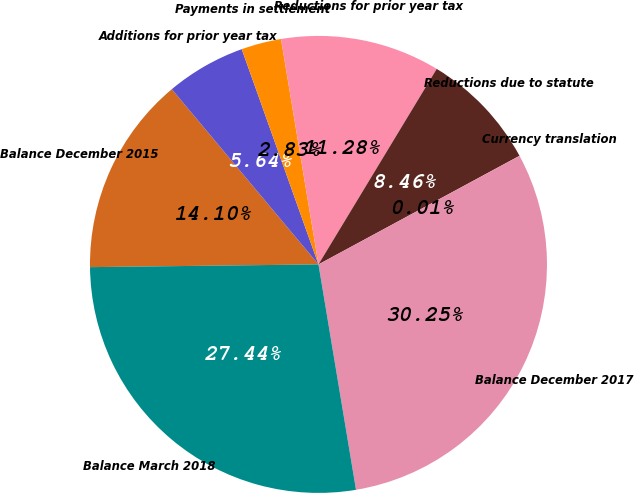Convert chart to OTSL. <chart><loc_0><loc_0><loc_500><loc_500><pie_chart><fcel>Balance December 2015<fcel>Additions for prior year tax<fcel>Payments in settlement<fcel>Reductions for prior year tax<fcel>Reductions due to statute<fcel>Currency translation<fcel>Balance December 2017<fcel>Balance March 2018<nl><fcel>14.1%<fcel>5.64%<fcel>2.83%<fcel>11.28%<fcel>8.46%<fcel>0.01%<fcel>30.25%<fcel>27.44%<nl></chart> 